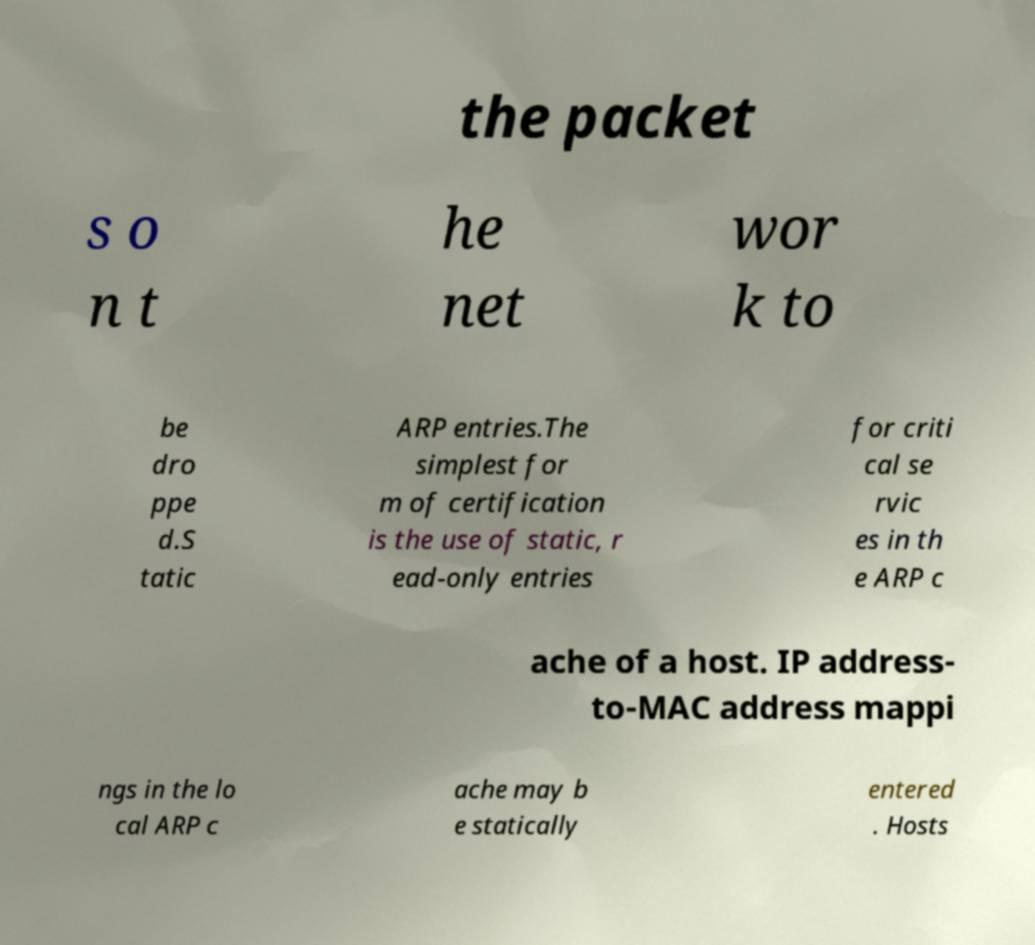For documentation purposes, I need the text within this image transcribed. Could you provide that? the packet s o n t he net wor k to be dro ppe d.S tatic ARP entries.The simplest for m of certification is the use of static, r ead-only entries for criti cal se rvic es in th e ARP c ache of a host. IP address- to-MAC address mappi ngs in the lo cal ARP c ache may b e statically entered . Hosts 